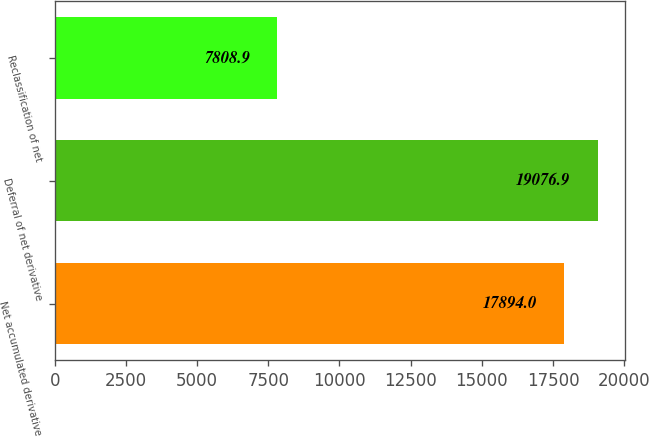<chart> <loc_0><loc_0><loc_500><loc_500><bar_chart><fcel>Net accumulated derivative<fcel>Deferral of net derivative<fcel>Reclassification of net<nl><fcel>17894<fcel>19076.9<fcel>7808.9<nl></chart> 